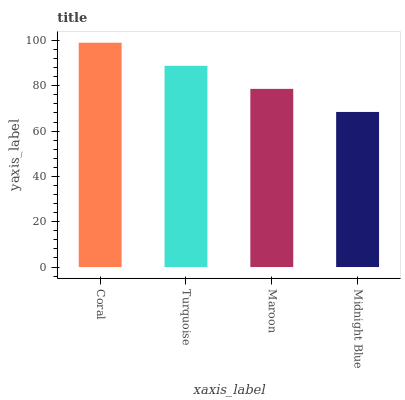Is Midnight Blue the minimum?
Answer yes or no. Yes. Is Coral the maximum?
Answer yes or no. Yes. Is Turquoise the minimum?
Answer yes or no. No. Is Turquoise the maximum?
Answer yes or no. No. Is Coral greater than Turquoise?
Answer yes or no. Yes. Is Turquoise less than Coral?
Answer yes or no. Yes. Is Turquoise greater than Coral?
Answer yes or no. No. Is Coral less than Turquoise?
Answer yes or no. No. Is Turquoise the high median?
Answer yes or no. Yes. Is Maroon the low median?
Answer yes or no. Yes. Is Maroon the high median?
Answer yes or no. No. Is Coral the low median?
Answer yes or no. No. 